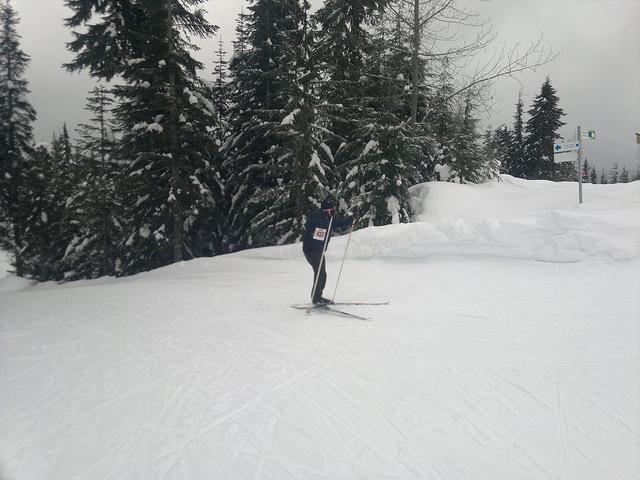Is this person touching the ground?
Give a very brief answer. Yes. Is the skier in motion?
Give a very brief answer. Yes. What sport is this person participating in?
Give a very brief answer. Skiing. What is this man standing on?
Answer briefly. Skis. How many people are skiing?
Answer briefly. 1. What is on the ground?
Short answer required. Snow. Is there dirt on the slope?
Write a very short answer. No. How many trees are in the snow?
Quick response, please. Many. Do you see an arrow?
Write a very short answer. Yes. 